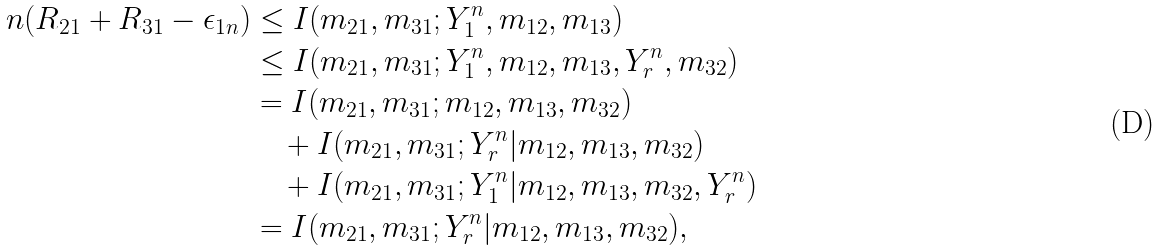<formula> <loc_0><loc_0><loc_500><loc_500>n ( R _ { 2 1 } + R _ { 3 1 } - \epsilon _ { 1 n } ) & \leq I ( m _ { 2 1 } , m _ { 3 1 } ; Y _ { 1 } ^ { n } , m _ { 1 2 } , m _ { 1 3 } ) \\ & \leq I ( m _ { 2 1 } , m _ { 3 1 } ; Y _ { 1 } ^ { n } , m _ { 1 2 } , m _ { 1 3 } , Y _ { r } ^ { n } , m _ { 3 2 } ) \\ & = I ( m _ { 2 1 } , m _ { 3 1 } ; m _ { 1 2 } , m _ { 1 3 } , m _ { 3 2 } ) \\ & \quad + I ( m _ { 2 1 } , m _ { 3 1 } ; Y _ { r } ^ { n } | m _ { 1 2 } , m _ { 1 3 } , m _ { 3 2 } ) \\ & \quad + I ( m _ { 2 1 } , m _ { 3 1 } ; Y _ { 1 } ^ { n } | m _ { 1 2 } , m _ { 1 3 } , m _ { 3 2 } , Y _ { r } ^ { n } ) \\ & = I ( m _ { 2 1 } , m _ { 3 1 } ; Y _ { r } ^ { n } | m _ { 1 2 } , m _ { 1 3 } , m _ { 3 2 } ) ,</formula> 